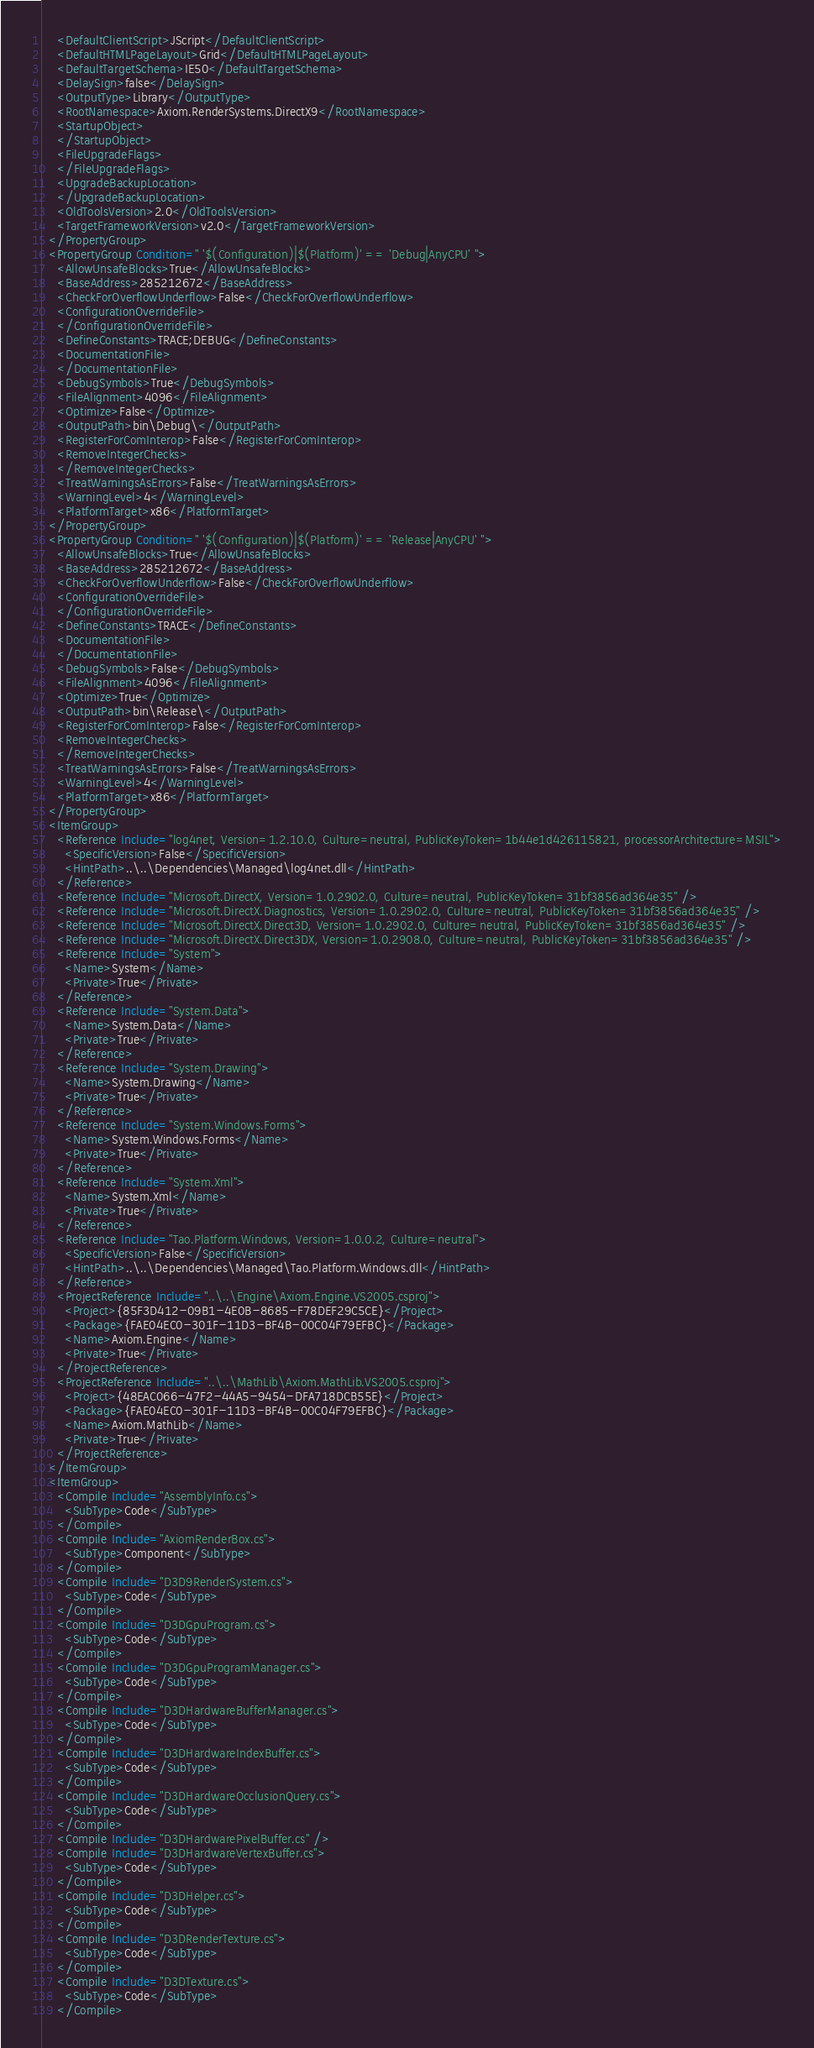<code> <loc_0><loc_0><loc_500><loc_500><_XML_>    <DefaultClientScript>JScript</DefaultClientScript>
    <DefaultHTMLPageLayout>Grid</DefaultHTMLPageLayout>
    <DefaultTargetSchema>IE50</DefaultTargetSchema>
    <DelaySign>false</DelaySign>
    <OutputType>Library</OutputType>
    <RootNamespace>Axiom.RenderSystems.DirectX9</RootNamespace>
    <StartupObject>
    </StartupObject>
    <FileUpgradeFlags>
    </FileUpgradeFlags>
    <UpgradeBackupLocation>
    </UpgradeBackupLocation>
    <OldToolsVersion>2.0</OldToolsVersion>
    <TargetFrameworkVersion>v2.0</TargetFrameworkVersion>
  </PropertyGroup>
  <PropertyGroup Condition=" '$(Configuration)|$(Platform)' == 'Debug|AnyCPU' ">
    <AllowUnsafeBlocks>True</AllowUnsafeBlocks>
    <BaseAddress>285212672</BaseAddress>
    <CheckForOverflowUnderflow>False</CheckForOverflowUnderflow>
    <ConfigurationOverrideFile>
    </ConfigurationOverrideFile>
    <DefineConstants>TRACE;DEBUG</DefineConstants>
    <DocumentationFile>
    </DocumentationFile>
    <DebugSymbols>True</DebugSymbols>
    <FileAlignment>4096</FileAlignment>
    <Optimize>False</Optimize>
    <OutputPath>bin\Debug\</OutputPath>
    <RegisterForComInterop>False</RegisterForComInterop>
    <RemoveIntegerChecks>
    </RemoveIntegerChecks>
    <TreatWarningsAsErrors>False</TreatWarningsAsErrors>
    <WarningLevel>4</WarningLevel>
    <PlatformTarget>x86</PlatformTarget>
  </PropertyGroup>
  <PropertyGroup Condition=" '$(Configuration)|$(Platform)' == 'Release|AnyCPU' ">
    <AllowUnsafeBlocks>True</AllowUnsafeBlocks>
    <BaseAddress>285212672</BaseAddress>
    <CheckForOverflowUnderflow>False</CheckForOverflowUnderflow>
    <ConfigurationOverrideFile>
    </ConfigurationOverrideFile>
    <DefineConstants>TRACE</DefineConstants>
    <DocumentationFile>
    </DocumentationFile>
    <DebugSymbols>False</DebugSymbols>
    <FileAlignment>4096</FileAlignment>
    <Optimize>True</Optimize>
    <OutputPath>bin\Release\</OutputPath>
    <RegisterForComInterop>False</RegisterForComInterop>
    <RemoveIntegerChecks>
    </RemoveIntegerChecks>
    <TreatWarningsAsErrors>False</TreatWarningsAsErrors>
    <WarningLevel>4</WarningLevel>
    <PlatformTarget>x86</PlatformTarget>
  </PropertyGroup>
  <ItemGroup>
    <Reference Include="log4net, Version=1.2.10.0, Culture=neutral, PublicKeyToken=1b44e1d426115821, processorArchitecture=MSIL">
      <SpecificVersion>False</SpecificVersion>
      <HintPath>..\..\Dependencies\Managed\log4net.dll</HintPath>
    </Reference>
    <Reference Include="Microsoft.DirectX, Version=1.0.2902.0, Culture=neutral, PublicKeyToken=31bf3856ad364e35" />
    <Reference Include="Microsoft.DirectX.Diagnostics, Version=1.0.2902.0, Culture=neutral, PublicKeyToken=31bf3856ad364e35" />
    <Reference Include="Microsoft.DirectX.Direct3D, Version=1.0.2902.0, Culture=neutral, PublicKeyToken=31bf3856ad364e35" />
    <Reference Include="Microsoft.DirectX.Direct3DX, Version=1.0.2908.0, Culture=neutral, PublicKeyToken=31bf3856ad364e35" />
    <Reference Include="System">
      <Name>System</Name>
      <Private>True</Private>
    </Reference>
    <Reference Include="System.Data">
      <Name>System.Data</Name>
      <Private>True</Private>
    </Reference>
    <Reference Include="System.Drawing">
      <Name>System.Drawing</Name>
      <Private>True</Private>
    </Reference>
    <Reference Include="System.Windows.Forms">
      <Name>System.Windows.Forms</Name>
      <Private>True</Private>
    </Reference>
    <Reference Include="System.Xml">
      <Name>System.Xml</Name>
      <Private>True</Private>
    </Reference>
    <Reference Include="Tao.Platform.Windows, Version=1.0.0.2, Culture=neutral">
      <SpecificVersion>False</SpecificVersion>
      <HintPath>..\..\Dependencies\Managed\Tao.Platform.Windows.dll</HintPath>
    </Reference>
    <ProjectReference Include="..\..\Engine\Axiom.Engine.VS2005.csproj">
      <Project>{85F3D412-09B1-4E0B-8685-F78DEF29C5CE}</Project>
      <Package>{FAE04EC0-301F-11D3-BF4B-00C04F79EFBC}</Package>
      <Name>Axiom.Engine</Name>
      <Private>True</Private>
    </ProjectReference>
    <ProjectReference Include="..\..\MathLib\Axiom.MathLib.VS2005.csproj">
      <Project>{48EAC066-47F2-44A5-9454-DFA718DCB55E}</Project>
      <Package>{FAE04EC0-301F-11D3-BF4B-00C04F79EFBC}</Package>
      <Name>Axiom.MathLib</Name>
      <Private>True</Private>
    </ProjectReference>
  </ItemGroup>
  <ItemGroup>
    <Compile Include="AssemblyInfo.cs">
      <SubType>Code</SubType>
    </Compile>
    <Compile Include="AxiomRenderBox.cs">
      <SubType>Component</SubType>
    </Compile>
    <Compile Include="D3D9RenderSystem.cs">
      <SubType>Code</SubType>
    </Compile>
    <Compile Include="D3DGpuProgram.cs">
      <SubType>Code</SubType>
    </Compile>
    <Compile Include="D3DGpuProgramManager.cs">
      <SubType>Code</SubType>
    </Compile>
    <Compile Include="D3DHardwareBufferManager.cs">
      <SubType>Code</SubType>
    </Compile>
    <Compile Include="D3DHardwareIndexBuffer.cs">
      <SubType>Code</SubType>
    </Compile>
    <Compile Include="D3DHardwareOcclusionQuery.cs">
      <SubType>Code</SubType>
    </Compile>
    <Compile Include="D3DHardwarePixelBuffer.cs" />
    <Compile Include="D3DHardwareVertexBuffer.cs">
      <SubType>Code</SubType>
    </Compile>
    <Compile Include="D3DHelper.cs">
      <SubType>Code</SubType>
    </Compile>
    <Compile Include="D3DRenderTexture.cs">
      <SubType>Code</SubType>
    </Compile>
    <Compile Include="D3DTexture.cs">
      <SubType>Code</SubType>
    </Compile></code> 